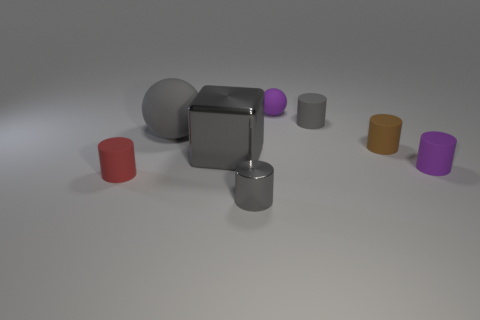There is another big object that is the same color as the big rubber object; what is its material?
Keep it short and to the point. Metal. How many brown cylinders are left of the gray rubber cylinder?
Ensure brevity in your answer.  0. Are there any tiny cylinders that have the same material as the purple ball?
Your response must be concise. Yes. What material is the purple thing that is the same size as the purple cylinder?
Give a very brief answer. Rubber. What is the size of the rubber thing that is both to the left of the small gray metal thing and behind the small red matte thing?
Make the answer very short. Large. What is the color of the tiny rubber object that is both to the left of the brown cylinder and in front of the big sphere?
Make the answer very short. Red. Is the number of tiny red rubber cylinders behind the big gray matte thing less than the number of tiny rubber objects behind the small red rubber cylinder?
Your answer should be very brief. Yes. What number of big green rubber objects are the same shape as the small gray metal thing?
Give a very brief answer. 0. What size is the purple cylinder that is the same material as the brown cylinder?
Give a very brief answer. Small. There is a small thing behind the small gray object behind the big gray ball; what color is it?
Your response must be concise. Purple. 